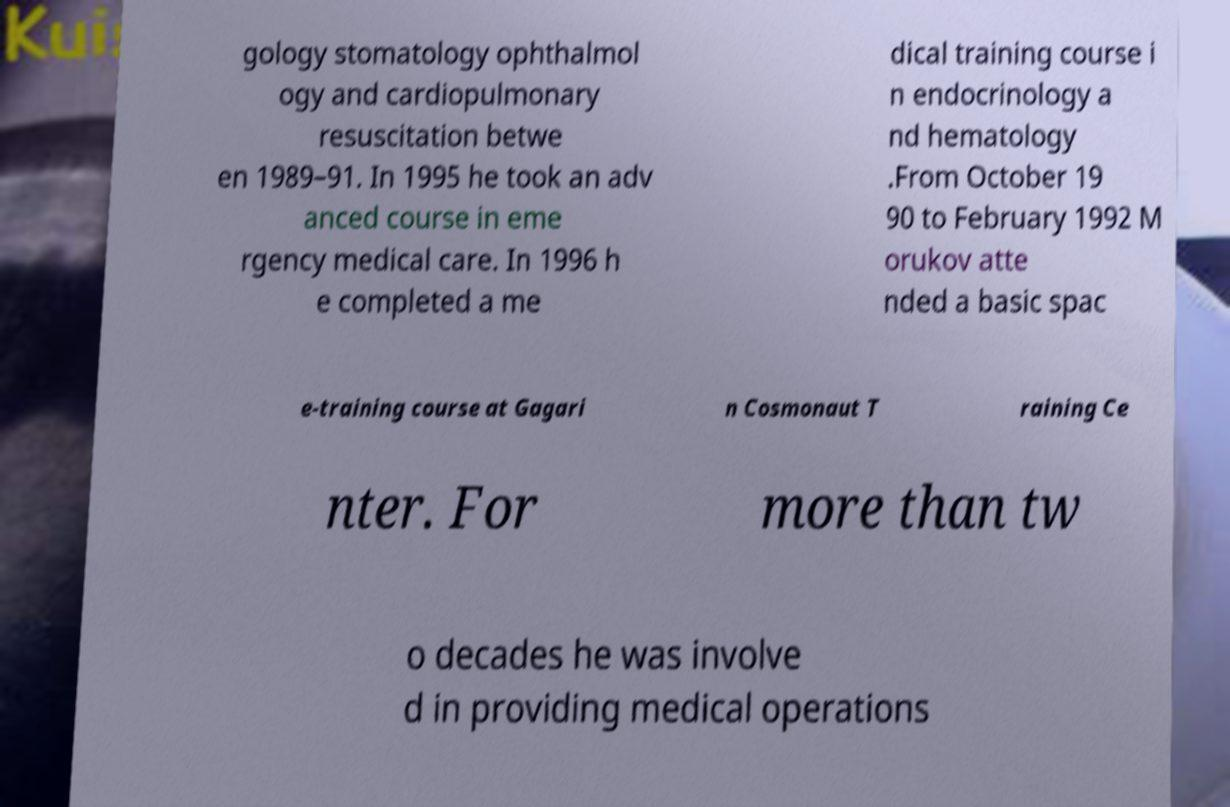Can you read and provide the text displayed in the image?This photo seems to have some interesting text. Can you extract and type it out for me? gology stomatology ophthalmol ogy and cardiopulmonary resuscitation betwe en 1989–91. In 1995 he took an adv anced course in eme rgency medical care. In 1996 h e completed a me dical training course i n endocrinology a nd hematology .From October 19 90 to February 1992 M orukov atte nded a basic spac e-training course at Gagari n Cosmonaut T raining Ce nter. For more than tw o decades he was involve d in providing medical operations 